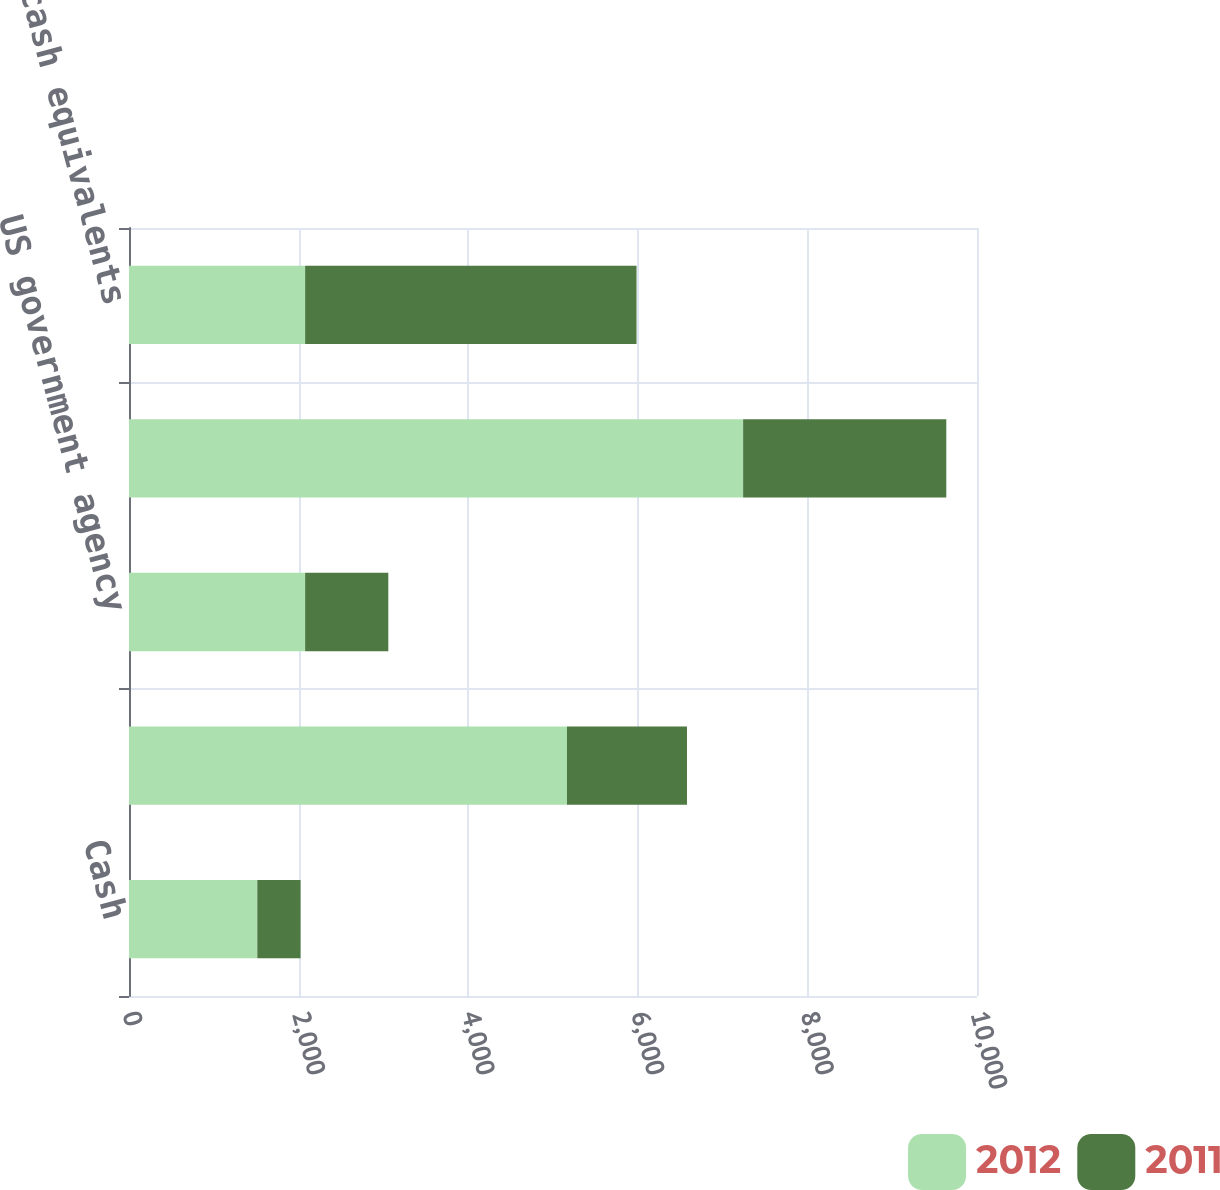Convert chart to OTSL. <chart><loc_0><loc_0><loc_500><loc_500><stacked_bar_chart><ecel><fcel>Cash<fcel>US government securities<fcel>US government agency<fcel>Total marketable securities<fcel>Total cash cash equivalents<nl><fcel>2012<fcel>1513<fcel>5165<fcel>2077<fcel>7242<fcel>2077<nl><fcel>2011<fcel>510<fcel>1415<fcel>981<fcel>2396<fcel>3908<nl></chart> 